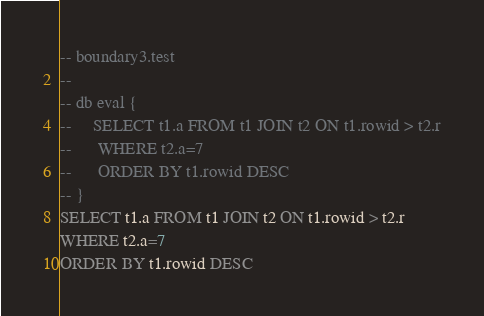<code> <loc_0><loc_0><loc_500><loc_500><_SQL_>-- boundary3.test
-- 
-- db eval {
--     SELECT t1.a FROM t1 JOIN t2 ON t1.rowid > t2.r
--      WHERE t2.a=7
--      ORDER BY t1.rowid DESC
-- }
SELECT t1.a FROM t1 JOIN t2 ON t1.rowid > t2.r
WHERE t2.a=7
ORDER BY t1.rowid DESC</code> 